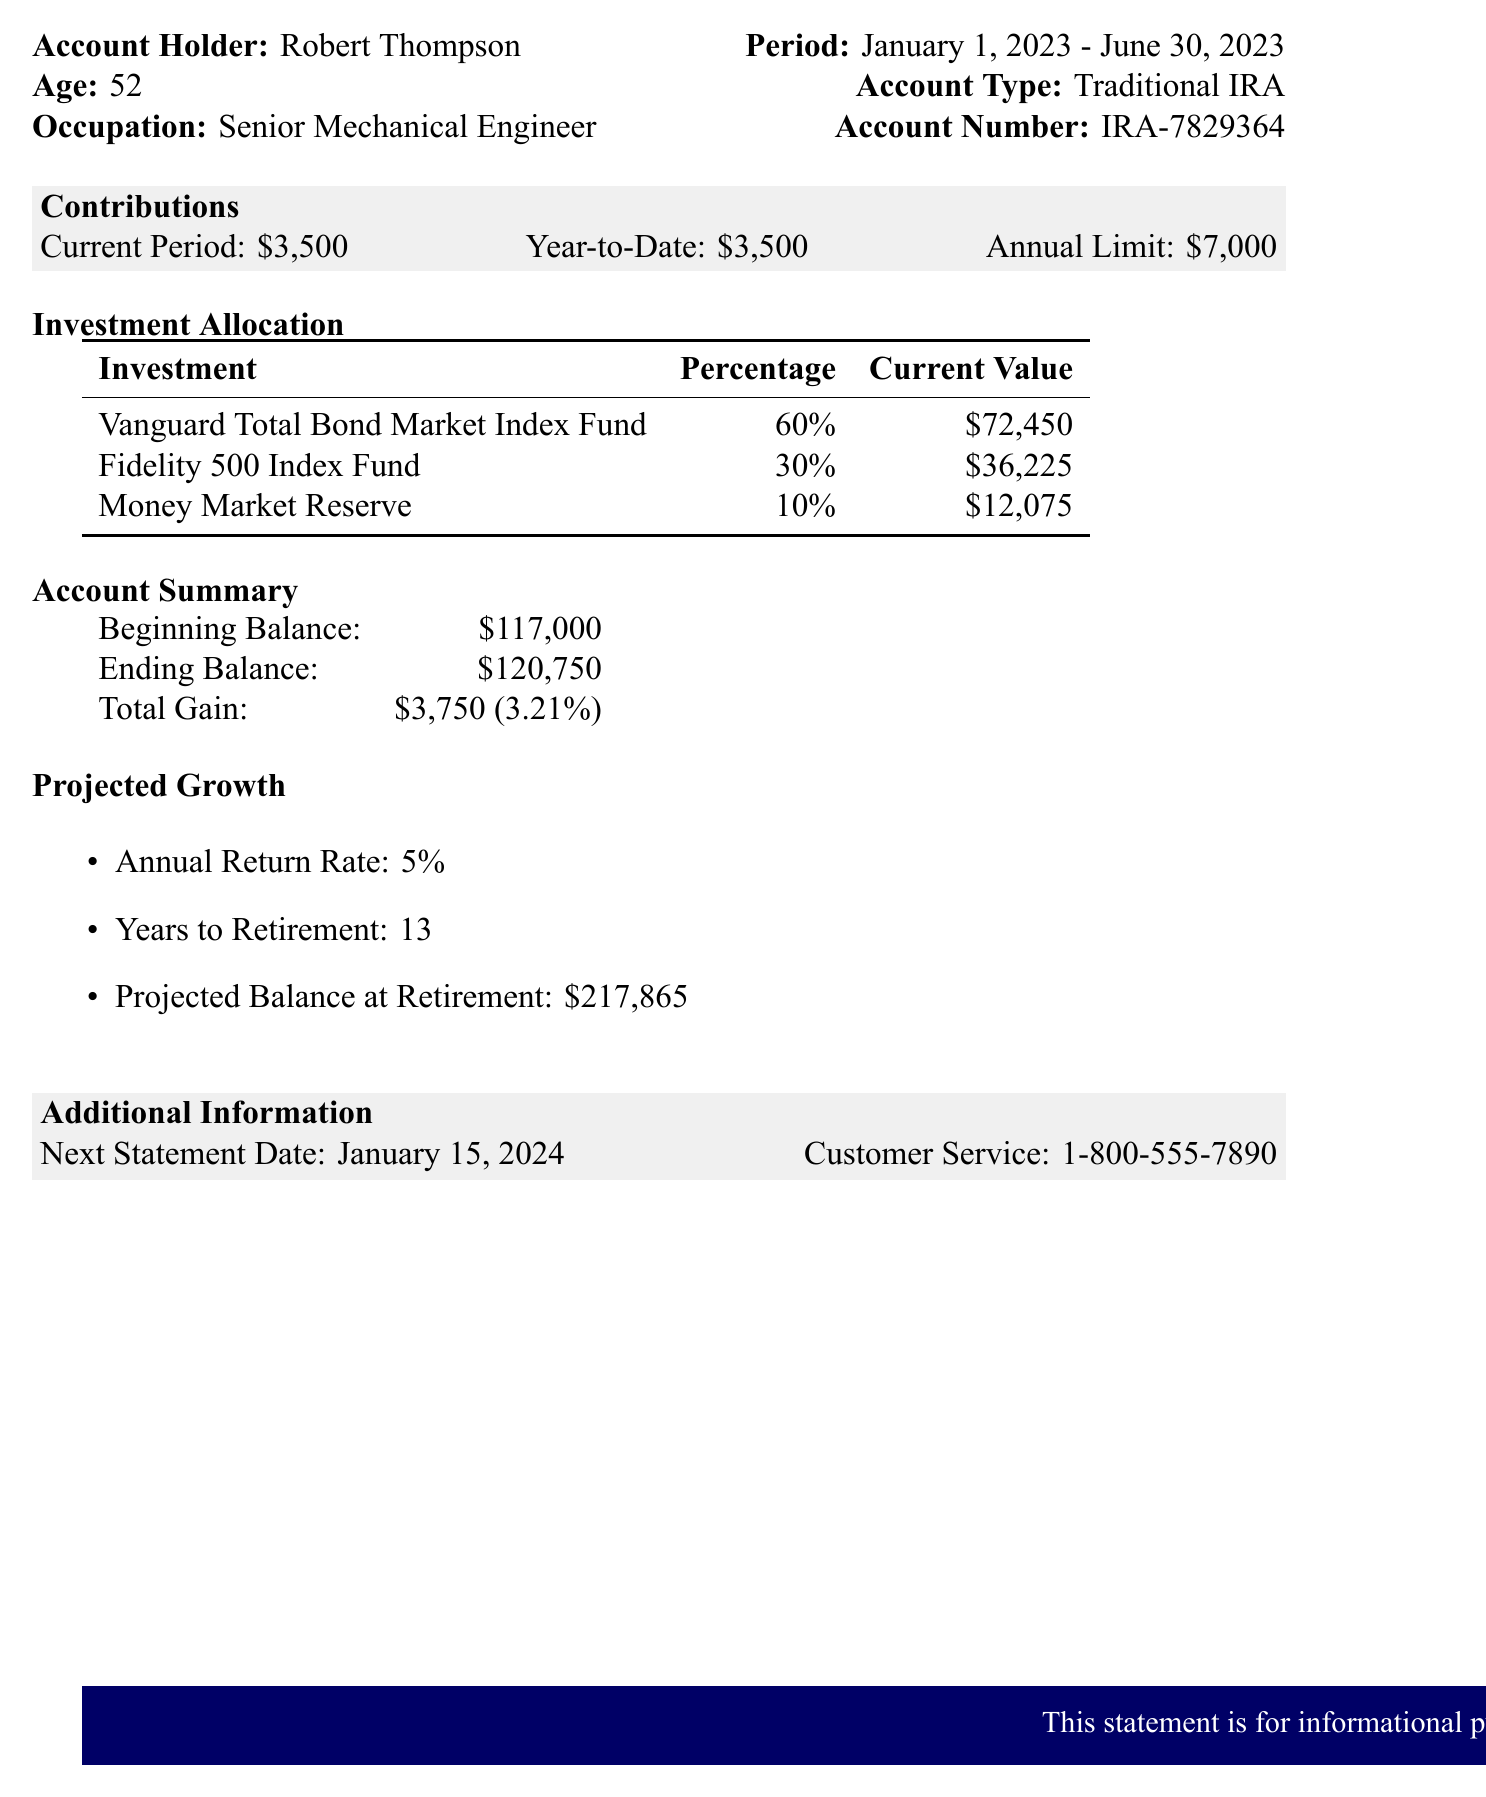What is the name of the account holder? The account holder's name is listed at the beginning of the document.
Answer: Robert Thompson What is the annual contribution limit for the Traditional IRA? The annual limit for contributions is specified in the contributions section of the document.
Answer: $7,000 What is the current value of the Vanguard Total Bond Market Index Fund? The current value of the Vanguard Total Bond Market Index Fund is found in the investment allocation section.
Answer: $72,450 What is the percentage gain for the account over the period? The percentage gain can be calculated from the account summary section.
Answer: 3.21% How many years does Robert have until retirement? The years to retirement is stated in the projected growth section of the document.
Answer: 13 What is the projected balance at retirement? The projected balance at retirement is detailed in the projected growth section.
Answer: $217,865 What is the beginning balance of the account? The beginning balance is mentioned in the account summary section.
Answer: $117,000 When is the next statement date? The date of the next statement is listed in the additional information section.
Answer: January 15, 2024 What type of IRA is mentioned in the statement? The type of IRA is specified in the statement details at the top of the document.
Answer: Traditional IRA 